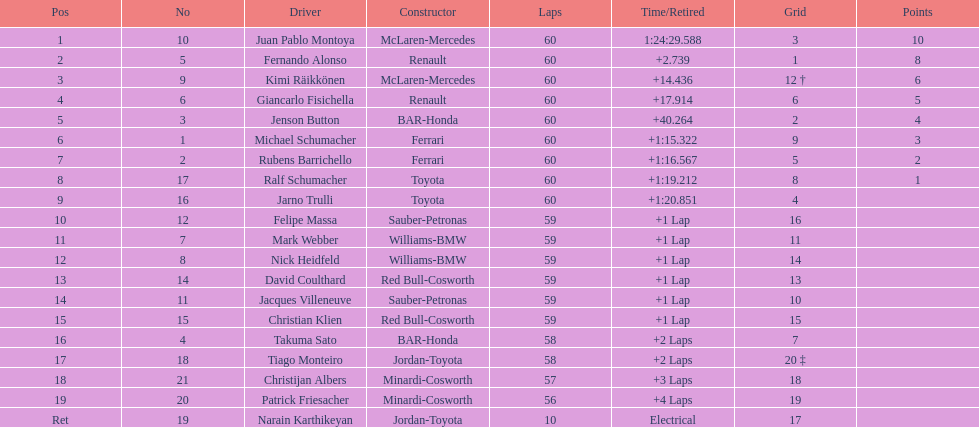Which driver has the least amount of points? Ralf Schumacher. 